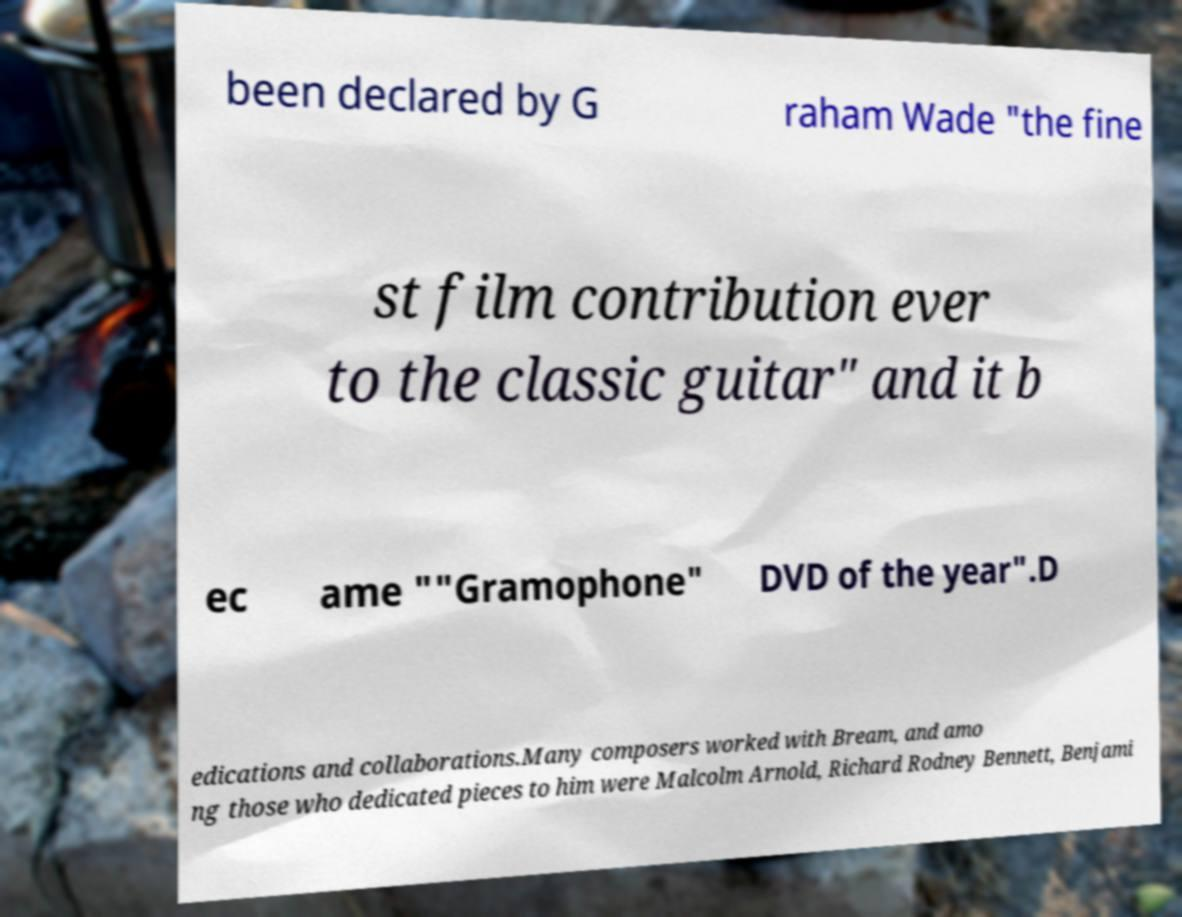There's text embedded in this image that I need extracted. Can you transcribe it verbatim? been declared by G raham Wade "the fine st film contribution ever to the classic guitar" and it b ec ame ""Gramophone" DVD of the year".D edications and collaborations.Many composers worked with Bream, and amo ng those who dedicated pieces to him were Malcolm Arnold, Richard Rodney Bennett, Benjami 